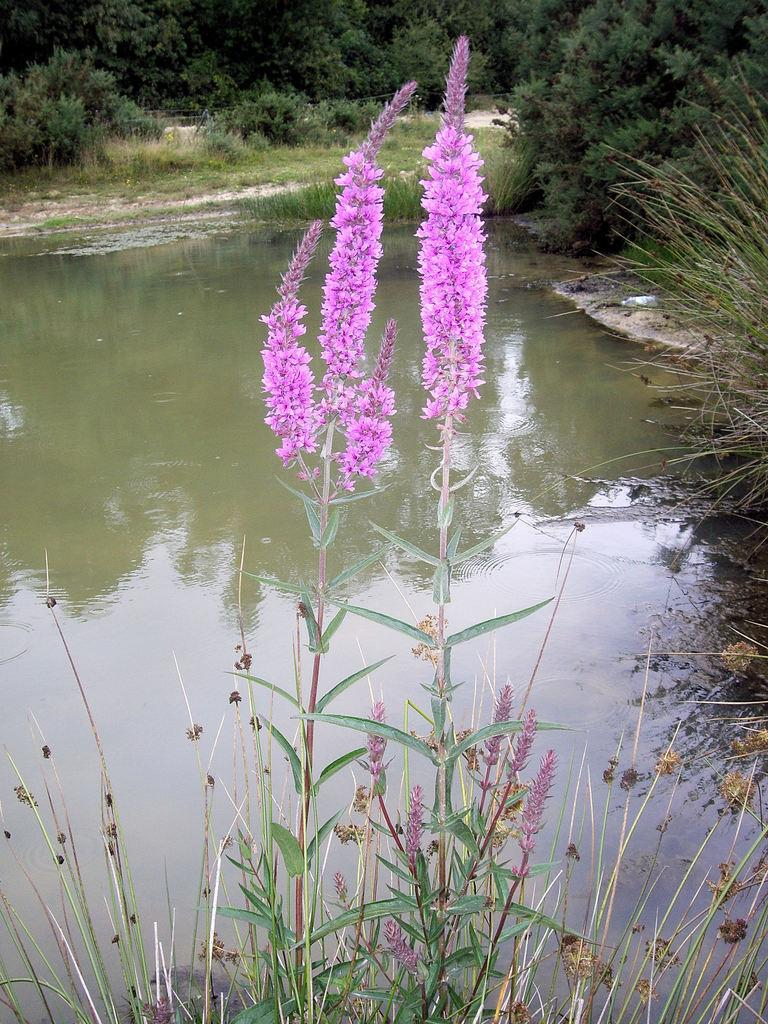What type of plants can be seen in the image? There are plants with flowers in the image. What can be seen in the background of the image? There is water, plants, and trees visible in the background of the image. What is the condition of the flowers in the image? The condition of the flowers cannot be determined from the image alone, as it only provides a visual representation of the plants and their surroundings. --- 